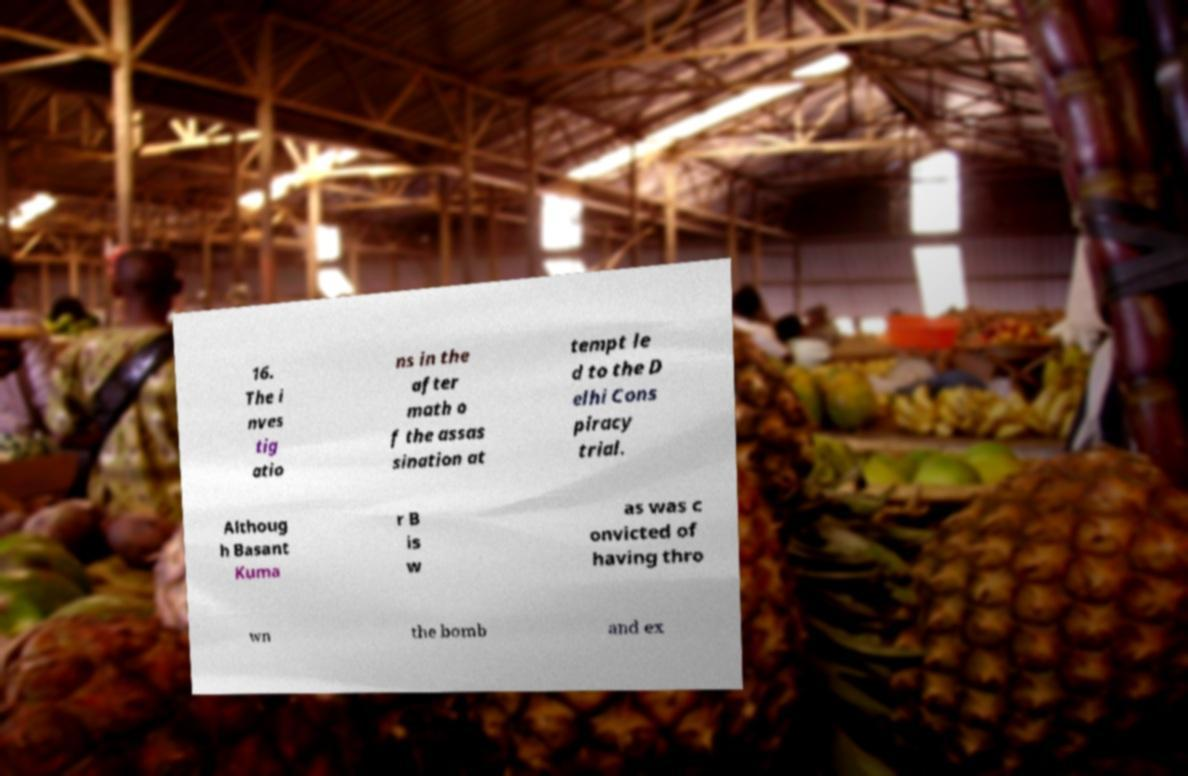Can you read and provide the text displayed in the image?This photo seems to have some interesting text. Can you extract and type it out for me? 16. The i nves tig atio ns in the after math o f the assas sination at tempt le d to the D elhi Cons piracy trial. Althoug h Basant Kuma r B is w as was c onvicted of having thro wn the bomb and ex 